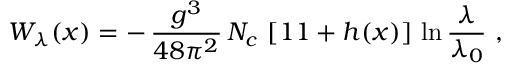Convert formula to latex. <formula><loc_0><loc_0><loc_500><loc_500>W _ { \lambda } ( x ) = - \, { \frac { g ^ { 3 } } { 4 8 \pi ^ { 2 } } } \, N _ { c } \, \left [ 1 1 + h ( x ) \right ] \, \ln { \frac { \lambda } { \lambda _ { 0 } } } \, ,</formula> 